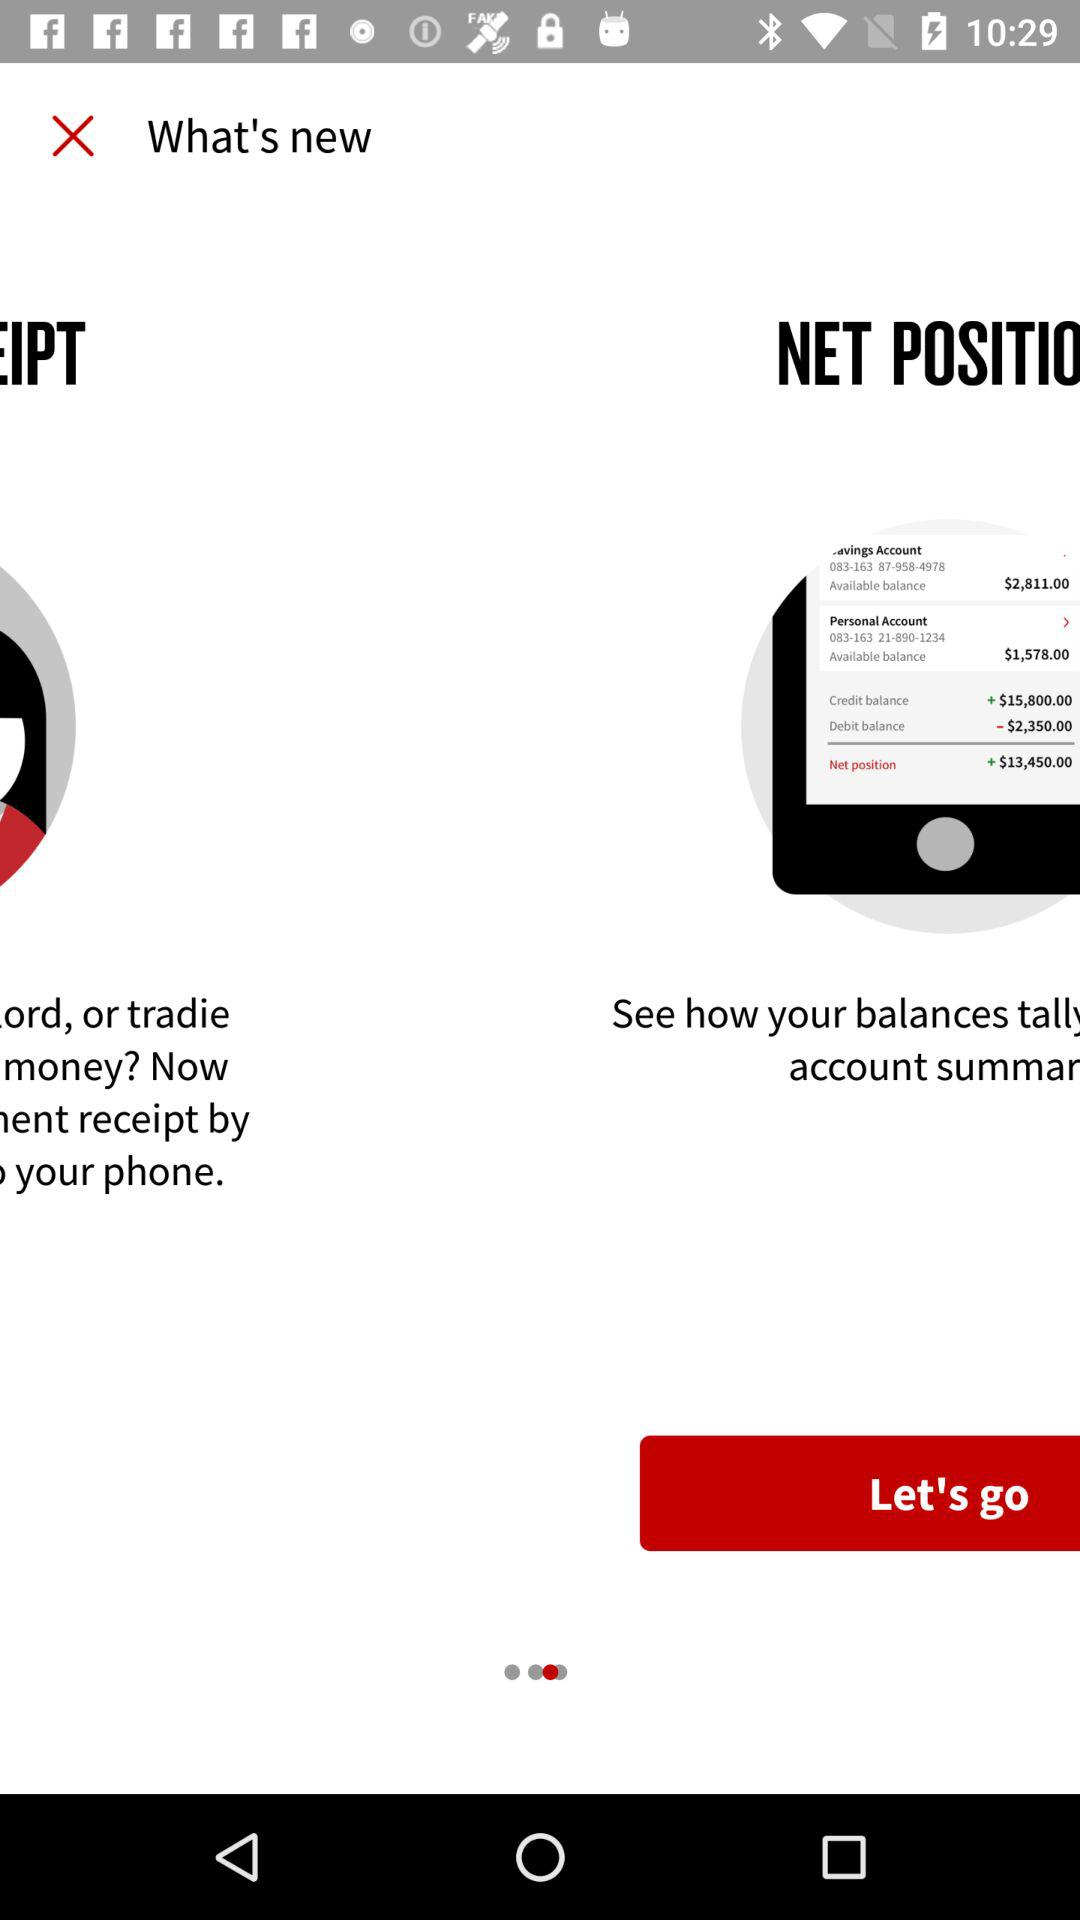What is the available balance on a personal account? The available balance on a personal account is $1,578.00. 